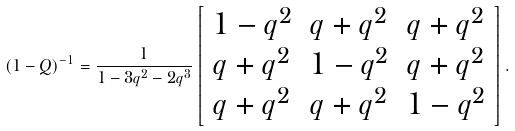Convert formula to latex. <formula><loc_0><loc_0><loc_500><loc_500>( 1 - Q ) ^ { - 1 } = \frac { 1 } { 1 - 3 q ^ { 2 } - 2 q ^ { 3 } } \left [ \begin{array} { c c c } 1 - q ^ { 2 } & q + q ^ { 2 } & q + q ^ { 2 } \\ q + q ^ { 2 } & 1 - q ^ { 2 } & q + q ^ { 2 } \\ q + q ^ { 2 } & q + q ^ { 2 } & 1 - q ^ { 2 } \end{array} \right ] .</formula> 